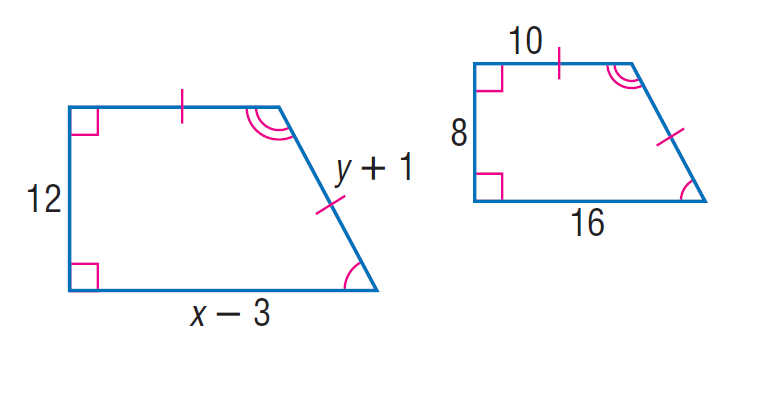Question: Each pair of polygons is similar. Find x.
Choices:
A. 8
B. 20
C. 27
D. 820
Answer with the letter. Answer: C Question: Each pair of polygons is similar. Find y.
Choices:
A. 12
B. 14
C. 20
D. 88
Answer with the letter. Answer: B 